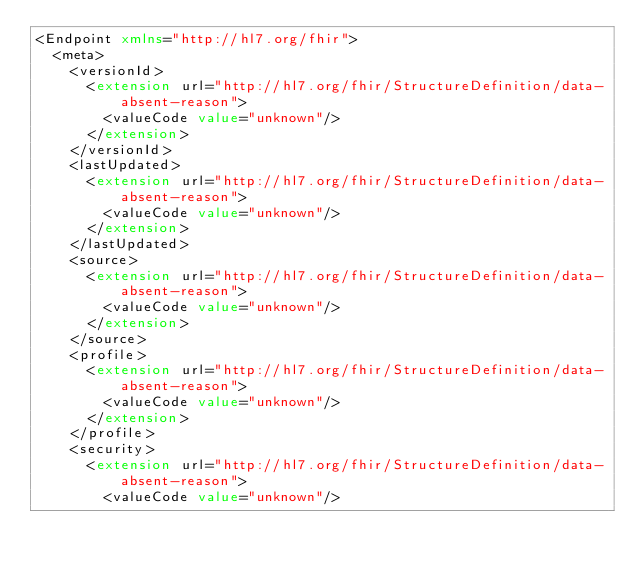<code> <loc_0><loc_0><loc_500><loc_500><_XML_><Endpoint xmlns="http://hl7.org/fhir">
  <meta>
    <versionId>
      <extension url="http://hl7.org/fhir/StructureDefinition/data-absent-reason">
        <valueCode value="unknown"/>
      </extension>
    </versionId>
    <lastUpdated>
      <extension url="http://hl7.org/fhir/StructureDefinition/data-absent-reason">
        <valueCode value="unknown"/>
      </extension>
    </lastUpdated>
    <source>
      <extension url="http://hl7.org/fhir/StructureDefinition/data-absent-reason">
        <valueCode value="unknown"/>
      </extension>
    </source>
    <profile>
      <extension url="http://hl7.org/fhir/StructureDefinition/data-absent-reason">
        <valueCode value="unknown"/>
      </extension>
    </profile>
    <security>
      <extension url="http://hl7.org/fhir/StructureDefinition/data-absent-reason">
        <valueCode value="unknown"/></code> 